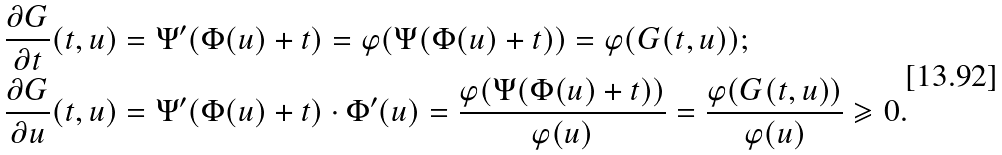<formula> <loc_0><loc_0><loc_500><loc_500>\frac { \partial G } { \partial t } ( t , u ) & = \Psi ^ { \prime } ( \Phi ( u ) + t ) = \varphi ( \Psi ( \Phi ( u ) + t ) ) = \varphi ( G ( t , u ) ) ; \\ \frac { \partial G } { \partial u } ( t , u ) & = \Psi ^ { \prime } ( \Phi ( u ) + t ) \cdot \Phi ^ { \prime } ( u ) = \frac { \varphi ( \Psi ( \Phi ( u ) + t ) ) } { \varphi ( u ) } = \frac { \varphi ( G ( t , u ) ) } { \varphi ( u ) } \geqslant 0 .</formula> 